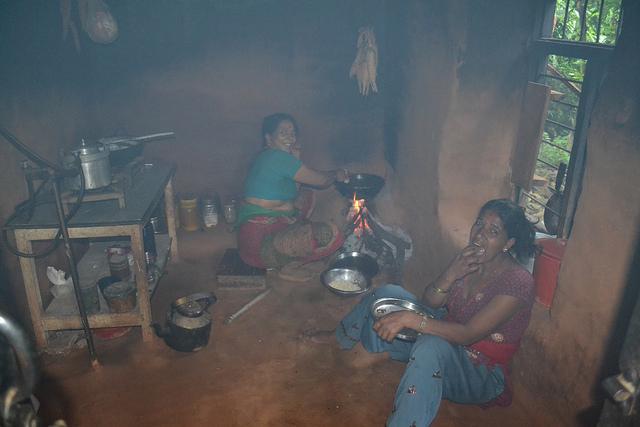Is the floor tiled?
Answer briefly. No. How many windows?
Be succinct. 2. What is on the table?
Quick response, please. Pots. What is sitting on the shoes?
Keep it brief. No shoes. 